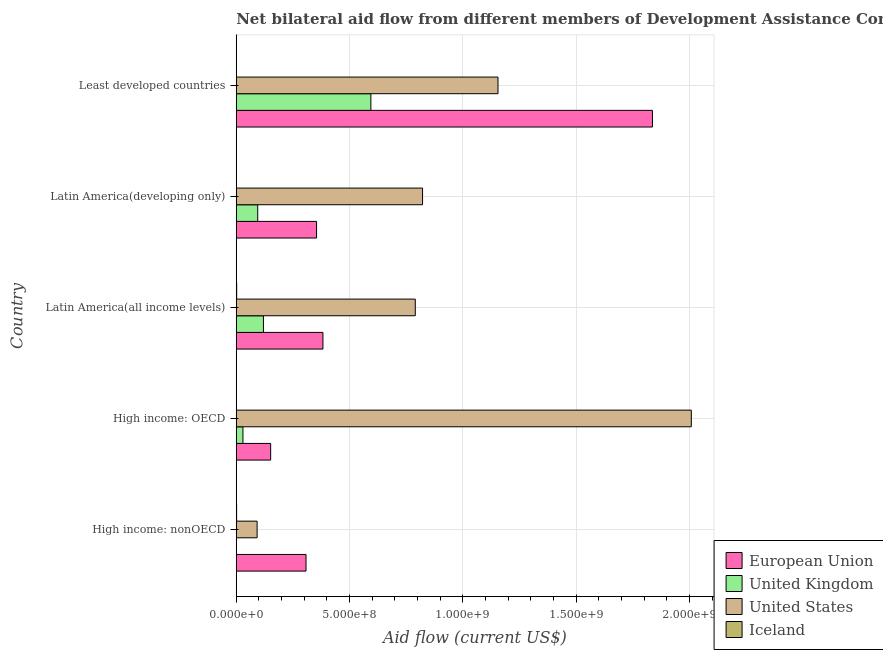How many groups of bars are there?
Your answer should be compact. 5. Are the number of bars per tick equal to the number of legend labels?
Offer a terse response. No. How many bars are there on the 3rd tick from the top?
Your answer should be compact. 4. What is the label of the 4th group of bars from the top?
Offer a terse response. High income: OECD. In how many cases, is the number of bars for a given country not equal to the number of legend labels?
Provide a short and direct response. 1. What is the amount of aid given by iceland in High income: nonOECD?
Make the answer very short. 1.55e+06. Across all countries, what is the maximum amount of aid given by us?
Your response must be concise. 2.01e+09. Across all countries, what is the minimum amount of aid given by eu?
Your answer should be compact. 1.52e+08. In which country was the amount of aid given by eu maximum?
Your answer should be very brief. Least developed countries. What is the total amount of aid given by us in the graph?
Your response must be concise. 4.87e+09. What is the difference between the amount of aid given by us in High income: nonOECD and that in Least developed countries?
Give a very brief answer. -1.06e+09. What is the difference between the amount of aid given by iceland in Least developed countries and the amount of aid given by eu in Latin America(all income levels)?
Your answer should be very brief. -3.82e+08. What is the average amount of aid given by eu per country?
Offer a very short reply. 6.07e+08. What is the difference between the amount of aid given by us and amount of aid given by eu in Latin America(developing only)?
Offer a very short reply. 4.68e+08. What is the difference between the highest and the second highest amount of aid given by us?
Make the answer very short. 8.53e+08. What is the difference between the highest and the lowest amount of aid given by eu?
Your answer should be compact. 1.68e+09. In how many countries, is the amount of aid given by eu greater than the average amount of aid given by eu taken over all countries?
Offer a very short reply. 1. Is it the case that in every country, the sum of the amount of aid given by eu and amount of aid given by uk is greater than the amount of aid given by us?
Your answer should be very brief. No. How many countries are there in the graph?
Your response must be concise. 5. What is the difference between two consecutive major ticks on the X-axis?
Keep it short and to the point. 5.00e+08. Where does the legend appear in the graph?
Give a very brief answer. Bottom right. How many legend labels are there?
Your answer should be compact. 4. How are the legend labels stacked?
Offer a terse response. Vertical. What is the title of the graph?
Make the answer very short. Net bilateral aid flow from different members of Development Assistance Committee in the year 1992. Does "Environmental sustainability" appear as one of the legend labels in the graph?
Your response must be concise. No. What is the label or title of the X-axis?
Ensure brevity in your answer.  Aid flow (current US$). What is the label or title of the Y-axis?
Provide a short and direct response. Country. What is the Aid flow (current US$) in European Union in High income: nonOECD?
Give a very brief answer. 3.08e+08. What is the Aid flow (current US$) of United Kingdom in High income: nonOECD?
Keep it short and to the point. 0. What is the Aid flow (current US$) in United States in High income: nonOECD?
Provide a short and direct response. 9.20e+07. What is the Aid flow (current US$) in Iceland in High income: nonOECD?
Ensure brevity in your answer.  1.55e+06. What is the Aid flow (current US$) in European Union in High income: OECD?
Ensure brevity in your answer.  1.52e+08. What is the Aid flow (current US$) in United Kingdom in High income: OECD?
Offer a very short reply. 2.95e+07. What is the Aid flow (current US$) of United States in High income: OECD?
Give a very brief answer. 2.01e+09. What is the Aid flow (current US$) in Iceland in High income: OECD?
Your response must be concise. 7.00e+05. What is the Aid flow (current US$) of European Union in Latin America(all income levels)?
Provide a succinct answer. 3.82e+08. What is the Aid flow (current US$) of United Kingdom in Latin America(all income levels)?
Keep it short and to the point. 1.20e+08. What is the Aid flow (current US$) of United States in Latin America(all income levels)?
Provide a succinct answer. 7.90e+08. What is the Aid flow (current US$) in Iceland in Latin America(all income levels)?
Make the answer very short. 1.85e+06. What is the Aid flow (current US$) in European Union in Latin America(developing only)?
Provide a short and direct response. 3.54e+08. What is the Aid flow (current US$) in United Kingdom in Latin America(developing only)?
Offer a terse response. 9.48e+07. What is the Aid flow (current US$) of United States in Latin America(developing only)?
Give a very brief answer. 8.22e+08. What is the Aid flow (current US$) of Iceland in Latin America(developing only)?
Your response must be concise. 1.00e+05. What is the Aid flow (current US$) of European Union in Least developed countries?
Offer a very short reply. 1.84e+09. What is the Aid flow (current US$) in United Kingdom in Least developed countries?
Offer a very short reply. 5.94e+08. What is the Aid flow (current US$) in United States in Least developed countries?
Your answer should be compact. 1.16e+09. What is the Aid flow (current US$) in Iceland in Least developed countries?
Your answer should be very brief. 7.50e+05. Across all countries, what is the maximum Aid flow (current US$) of European Union?
Make the answer very short. 1.84e+09. Across all countries, what is the maximum Aid flow (current US$) of United Kingdom?
Make the answer very short. 5.94e+08. Across all countries, what is the maximum Aid flow (current US$) of United States?
Provide a short and direct response. 2.01e+09. Across all countries, what is the maximum Aid flow (current US$) of Iceland?
Ensure brevity in your answer.  1.85e+06. Across all countries, what is the minimum Aid flow (current US$) of European Union?
Provide a short and direct response. 1.52e+08. Across all countries, what is the minimum Aid flow (current US$) of United Kingdom?
Offer a terse response. 0. Across all countries, what is the minimum Aid flow (current US$) in United States?
Give a very brief answer. 9.20e+07. Across all countries, what is the minimum Aid flow (current US$) in Iceland?
Provide a succinct answer. 1.00e+05. What is the total Aid flow (current US$) in European Union in the graph?
Provide a succinct answer. 3.03e+09. What is the total Aid flow (current US$) of United Kingdom in the graph?
Your answer should be compact. 8.38e+08. What is the total Aid flow (current US$) of United States in the graph?
Make the answer very short. 4.87e+09. What is the total Aid flow (current US$) of Iceland in the graph?
Make the answer very short. 4.95e+06. What is the difference between the Aid flow (current US$) of European Union in High income: nonOECD and that in High income: OECD?
Your response must be concise. 1.56e+08. What is the difference between the Aid flow (current US$) of United States in High income: nonOECD and that in High income: OECD?
Ensure brevity in your answer.  -1.92e+09. What is the difference between the Aid flow (current US$) of Iceland in High income: nonOECD and that in High income: OECD?
Keep it short and to the point. 8.50e+05. What is the difference between the Aid flow (current US$) of European Union in High income: nonOECD and that in Latin America(all income levels)?
Make the answer very short. -7.47e+07. What is the difference between the Aid flow (current US$) of United States in High income: nonOECD and that in Latin America(all income levels)?
Keep it short and to the point. -6.98e+08. What is the difference between the Aid flow (current US$) of Iceland in High income: nonOECD and that in Latin America(all income levels)?
Make the answer very short. -3.00e+05. What is the difference between the Aid flow (current US$) in European Union in High income: nonOECD and that in Latin America(developing only)?
Offer a terse response. -4.66e+07. What is the difference between the Aid flow (current US$) in United States in High income: nonOECD and that in Latin America(developing only)?
Provide a short and direct response. -7.30e+08. What is the difference between the Aid flow (current US$) in Iceland in High income: nonOECD and that in Latin America(developing only)?
Your answer should be very brief. 1.45e+06. What is the difference between the Aid flow (current US$) of European Union in High income: nonOECD and that in Least developed countries?
Give a very brief answer. -1.53e+09. What is the difference between the Aid flow (current US$) of United States in High income: nonOECD and that in Least developed countries?
Provide a short and direct response. -1.06e+09. What is the difference between the Aid flow (current US$) of European Union in High income: OECD and that in Latin America(all income levels)?
Provide a short and direct response. -2.31e+08. What is the difference between the Aid flow (current US$) in United Kingdom in High income: OECD and that in Latin America(all income levels)?
Your response must be concise. -9.05e+07. What is the difference between the Aid flow (current US$) of United States in High income: OECD and that in Latin America(all income levels)?
Give a very brief answer. 1.22e+09. What is the difference between the Aid flow (current US$) in Iceland in High income: OECD and that in Latin America(all income levels)?
Your response must be concise. -1.15e+06. What is the difference between the Aid flow (current US$) of European Union in High income: OECD and that in Latin America(developing only)?
Make the answer very short. -2.03e+08. What is the difference between the Aid flow (current US$) of United Kingdom in High income: OECD and that in Latin America(developing only)?
Your answer should be compact. -6.53e+07. What is the difference between the Aid flow (current US$) of United States in High income: OECD and that in Latin America(developing only)?
Your answer should be very brief. 1.19e+09. What is the difference between the Aid flow (current US$) in European Union in High income: OECD and that in Least developed countries?
Offer a terse response. -1.68e+09. What is the difference between the Aid flow (current US$) of United Kingdom in High income: OECD and that in Least developed countries?
Your answer should be very brief. -5.65e+08. What is the difference between the Aid flow (current US$) of United States in High income: OECD and that in Least developed countries?
Ensure brevity in your answer.  8.53e+08. What is the difference between the Aid flow (current US$) in European Union in Latin America(all income levels) and that in Latin America(developing only)?
Make the answer very short. 2.81e+07. What is the difference between the Aid flow (current US$) of United Kingdom in Latin America(all income levels) and that in Latin America(developing only)?
Ensure brevity in your answer.  2.52e+07. What is the difference between the Aid flow (current US$) of United States in Latin America(all income levels) and that in Latin America(developing only)?
Make the answer very short. -3.20e+07. What is the difference between the Aid flow (current US$) of Iceland in Latin America(all income levels) and that in Latin America(developing only)?
Provide a succinct answer. 1.75e+06. What is the difference between the Aid flow (current US$) in European Union in Latin America(all income levels) and that in Least developed countries?
Keep it short and to the point. -1.45e+09. What is the difference between the Aid flow (current US$) of United Kingdom in Latin America(all income levels) and that in Least developed countries?
Make the answer very short. -4.74e+08. What is the difference between the Aid flow (current US$) in United States in Latin America(all income levels) and that in Least developed countries?
Give a very brief answer. -3.65e+08. What is the difference between the Aid flow (current US$) in Iceland in Latin America(all income levels) and that in Least developed countries?
Ensure brevity in your answer.  1.10e+06. What is the difference between the Aid flow (current US$) in European Union in Latin America(developing only) and that in Least developed countries?
Make the answer very short. -1.48e+09. What is the difference between the Aid flow (current US$) in United Kingdom in Latin America(developing only) and that in Least developed countries?
Make the answer very short. -4.99e+08. What is the difference between the Aid flow (current US$) of United States in Latin America(developing only) and that in Least developed countries?
Give a very brief answer. -3.33e+08. What is the difference between the Aid flow (current US$) of Iceland in Latin America(developing only) and that in Least developed countries?
Your answer should be compact. -6.50e+05. What is the difference between the Aid flow (current US$) in European Union in High income: nonOECD and the Aid flow (current US$) in United Kingdom in High income: OECD?
Offer a terse response. 2.78e+08. What is the difference between the Aid flow (current US$) in European Union in High income: nonOECD and the Aid flow (current US$) in United States in High income: OECD?
Offer a terse response. -1.70e+09. What is the difference between the Aid flow (current US$) of European Union in High income: nonOECD and the Aid flow (current US$) of Iceland in High income: OECD?
Your answer should be very brief. 3.07e+08. What is the difference between the Aid flow (current US$) of United States in High income: nonOECD and the Aid flow (current US$) of Iceland in High income: OECD?
Make the answer very short. 9.13e+07. What is the difference between the Aid flow (current US$) in European Union in High income: nonOECD and the Aid flow (current US$) in United Kingdom in Latin America(all income levels)?
Provide a short and direct response. 1.88e+08. What is the difference between the Aid flow (current US$) of European Union in High income: nonOECD and the Aid flow (current US$) of United States in Latin America(all income levels)?
Keep it short and to the point. -4.82e+08. What is the difference between the Aid flow (current US$) in European Union in High income: nonOECD and the Aid flow (current US$) in Iceland in Latin America(all income levels)?
Make the answer very short. 3.06e+08. What is the difference between the Aid flow (current US$) in United States in High income: nonOECD and the Aid flow (current US$) in Iceland in Latin America(all income levels)?
Your answer should be very brief. 9.02e+07. What is the difference between the Aid flow (current US$) of European Union in High income: nonOECD and the Aid flow (current US$) of United Kingdom in Latin America(developing only)?
Your response must be concise. 2.13e+08. What is the difference between the Aid flow (current US$) in European Union in High income: nonOECD and the Aid flow (current US$) in United States in Latin America(developing only)?
Offer a terse response. -5.14e+08. What is the difference between the Aid flow (current US$) in European Union in High income: nonOECD and the Aid flow (current US$) in Iceland in Latin America(developing only)?
Your answer should be compact. 3.08e+08. What is the difference between the Aid flow (current US$) of United States in High income: nonOECD and the Aid flow (current US$) of Iceland in Latin America(developing only)?
Offer a very short reply. 9.19e+07. What is the difference between the Aid flow (current US$) of European Union in High income: nonOECD and the Aid flow (current US$) of United Kingdom in Least developed countries?
Provide a short and direct response. -2.86e+08. What is the difference between the Aid flow (current US$) of European Union in High income: nonOECD and the Aid flow (current US$) of United States in Least developed countries?
Your response must be concise. -8.47e+08. What is the difference between the Aid flow (current US$) in European Union in High income: nonOECD and the Aid flow (current US$) in Iceland in Least developed countries?
Ensure brevity in your answer.  3.07e+08. What is the difference between the Aid flow (current US$) of United States in High income: nonOECD and the Aid flow (current US$) of Iceland in Least developed countries?
Your answer should be compact. 9.12e+07. What is the difference between the Aid flow (current US$) in European Union in High income: OECD and the Aid flow (current US$) in United Kingdom in Latin America(all income levels)?
Your response must be concise. 3.18e+07. What is the difference between the Aid flow (current US$) in European Union in High income: OECD and the Aid flow (current US$) in United States in Latin America(all income levels)?
Offer a terse response. -6.38e+08. What is the difference between the Aid flow (current US$) of European Union in High income: OECD and the Aid flow (current US$) of Iceland in Latin America(all income levels)?
Provide a succinct answer. 1.50e+08. What is the difference between the Aid flow (current US$) of United Kingdom in High income: OECD and the Aid flow (current US$) of United States in Latin America(all income levels)?
Your response must be concise. -7.61e+08. What is the difference between the Aid flow (current US$) in United Kingdom in High income: OECD and the Aid flow (current US$) in Iceland in Latin America(all income levels)?
Your answer should be very brief. 2.76e+07. What is the difference between the Aid flow (current US$) in United States in High income: OECD and the Aid flow (current US$) in Iceland in Latin America(all income levels)?
Provide a short and direct response. 2.01e+09. What is the difference between the Aid flow (current US$) in European Union in High income: OECD and the Aid flow (current US$) in United Kingdom in Latin America(developing only)?
Your answer should be compact. 5.70e+07. What is the difference between the Aid flow (current US$) of European Union in High income: OECD and the Aid flow (current US$) of United States in Latin America(developing only)?
Provide a succinct answer. -6.70e+08. What is the difference between the Aid flow (current US$) of European Union in High income: OECD and the Aid flow (current US$) of Iceland in Latin America(developing only)?
Your answer should be very brief. 1.52e+08. What is the difference between the Aid flow (current US$) in United Kingdom in High income: OECD and the Aid flow (current US$) in United States in Latin America(developing only)?
Ensure brevity in your answer.  -7.93e+08. What is the difference between the Aid flow (current US$) in United Kingdom in High income: OECD and the Aid flow (current US$) in Iceland in Latin America(developing only)?
Offer a very short reply. 2.94e+07. What is the difference between the Aid flow (current US$) in United States in High income: OECD and the Aid flow (current US$) in Iceland in Latin America(developing only)?
Keep it short and to the point. 2.01e+09. What is the difference between the Aid flow (current US$) in European Union in High income: OECD and the Aid flow (current US$) in United Kingdom in Least developed countries?
Provide a succinct answer. -4.42e+08. What is the difference between the Aid flow (current US$) of European Union in High income: OECD and the Aid flow (current US$) of United States in Least developed countries?
Your answer should be compact. -1.00e+09. What is the difference between the Aid flow (current US$) in European Union in High income: OECD and the Aid flow (current US$) in Iceland in Least developed countries?
Ensure brevity in your answer.  1.51e+08. What is the difference between the Aid flow (current US$) in United Kingdom in High income: OECD and the Aid flow (current US$) in United States in Least developed countries?
Provide a succinct answer. -1.13e+09. What is the difference between the Aid flow (current US$) of United Kingdom in High income: OECD and the Aid flow (current US$) of Iceland in Least developed countries?
Offer a terse response. 2.87e+07. What is the difference between the Aid flow (current US$) of United States in High income: OECD and the Aid flow (current US$) of Iceland in Least developed countries?
Your response must be concise. 2.01e+09. What is the difference between the Aid flow (current US$) in European Union in Latin America(all income levels) and the Aid flow (current US$) in United Kingdom in Latin America(developing only)?
Make the answer very short. 2.88e+08. What is the difference between the Aid flow (current US$) of European Union in Latin America(all income levels) and the Aid flow (current US$) of United States in Latin America(developing only)?
Provide a succinct answer. -4.40e+08. What is the difference between the Aid flow (current US$) in European Union in Latin America(all income levels) and the Aid flow (current US$) in Iceland in Latin America(developing only)?
Your response must be concise. 3.82e+08. What is the difference between the Aid flow (current US$) of United Kingdom in Latin America(all income levels) and the Aid flow (current US$) of United States in Latin America(developing only)?
Your answer should be compact. -7.02e+08. What is the difference between the Aid flow (current US$) of United Kingdom in Latin America(all income levels) and the Aid flow (current US$) of Iceland in Latin America(developing only)?
Your answer should be very brief. 1.20e+08. What is the difference between the Aid flow (current US$) of United States in Latin America(all income levels) and the Aid flow (current US$) of Iceland in Latin America(developing only)?
Offer a terse response. 7.90e+08. What is the difference between the Aid flow (current US$) in European Union in Latin America(all income levels) and the Aid flow (current US$) in United Kingdom in Least developed countries?
Make the answer very short. -2.12e+08. What is the difference between the Aid flow (current US$) of European Union in Latin America(all income levels) and the Aid flow (current US$) of United States in Least developed countries?
Give a very brief answer. -7.73e+08. What is the difference between the Aid flow (current US$) in European Union in Latin America(all income levels) and the Aid flow (current US$) in Iceland in Least developed countries?
Provide a succinct answer. 3.82e+08. What is the difference between the Aid flow (current US$) in United Kingdom in Latin America(all income levels) and the Aid flow (current US$) in United States in Least developed countries?
Offer a very short reply. -1.04e+09. What is the difference between the Aid flow (current US$) in United Kingdom in Latin America(all income levels) and the Aid flow (current US$) in Iceland in Least developed countries?
Offer a very short reply. 1.19e+08. What is the difference between the Aid flow (current US$) of United States in Latin America(all income levels) and the Aid flow (current US$) of Iceland in Least developed countries?
Ensure brevity in your answer.  7.89e+08. What is the difference between the Aid flow (current US$) in European Union in Latin America(developing only) and the Aid flow (current US$) in United Kingdom in Least developed countries?
Ensure brevity in your answer.  -2.40e+08. What is the difference between the Aid flow (current US$) in European Union in Latin America(developing only) and the Aid flow (current US$) in United States in Least developed countries?
Offer a terse response. -8.01e+08. What is the difference between the Aid flow (current US$) of European Union in Latin America(developing only) and the Aid flow (current US$) of Iceland in Least developed countries?
Offer a very short reply. 3.54e+08. What is the difference between the Aid flow (current US$) in United Kingdom in Latin America(developing only) and the Aid flow (current US$) in United States in Least developed countries?
Make the answer very short. -1.06e+09. What is the difference between the Aid flow (current US$) of United Kingdom in Latin America(developing only) and the Aid flow (current US$) of Iceland in Least developed countries?
Provide a succinct answer. 9.40e+07. What is the difference between the Aid flow (current US$) in United States in Latin America(developing only) and the Aid flow (current US$) in Iceland in Least developed countries?
Your answer should be very brief. 8.21e+08. What is the average Aid flow (current US$) of European Union per country?
Ensure brevity in your answer.  6.07e+08. What is the average Aid flow (current US$) of United Kingdom per country?
Your response must be concise. 1.68e+08. What is the average Aid flow (current US$) in United States per country?
Give a very brief answer. 9.73e+08. What is the average Aid flow (current US$) of Iceland per country?
Provide a short and direct response. 9.90e+05. What is the difference between the Aid flow (current US$) in European Union and Aid flow (current US$) in United States in High income: nonOECD?
Offer a very short reply. 2.16e+08. What is the difference between the Aid flow (current US$) of European Union and Aid flow (current US$) of Iceland in High income: nonOECD?
Provide a short and direct response. 3.06e+08. What is the difference between the Aid flow (current US$) of United States and Aid flow (current US$) of Iceland in High income: nonOECD?
Your answer should be very brief. 9.04e+07. What is the difference between the Aid flow (current US$) of European Union and Aid flow (current US$) of United Kingdom in High income: OECD?
Offer a very short reply. 1.22e+08. What is the difference between the Aid flow (current US$) in European Union and Aid flow (current US$) in United States in High income: OECD?
Your response must be concise. -1.86e+09. What is the difference between the Aid flow (current US$) of European Union and Aid flow (current US$) of Iceland in High income: OECD?
Keep it short and to the point. 1.51e+08. What is the difference between the Aid flow (current US$) in United Kingdom and Aid flow (current US$) in United States in High income: OECD?
Your answer should be compact. -1.98e+09. What is the difference between the Aid flow (current US$) in United Kingdom and Aid flow (current US$) in Iceland in High income: OECD?
Provide a short and direct response. 2.88e+07. What is the difference between the Aid flow (current US$) in United States and Aid flow (current US$) in Iceland in High income: OECD?
Provide a succinct answer. 2.01e+09. What is the difference between the Aid flow (current US$) in European Union and Aid flow (current US$) in United Kingdom in Latin America(all income levels)?
Provide a short and direct response. 2.63e+08. What is the difference between the Aid flow (current US$) in European Union and Aid flow (current US$) in United States in Latin America(all income levels)?
Give a very brief answer. -4.08e+08. What is the difference between the Aid flow (current US$) in European Union and Aid flow (current US$) in Iceland in Latin America(all income levels)?
Provide a succinct answer. 3.81e+08. What is the difference between the Aid flow (current US$) of United Kingdom and Aid flow (current US$) of United States in Latin America(all income levels)?
Keep it short and to the point. -6.70e+08. What is the difference between the Aid flow (current US$) of United Kingdom and Aid flow (current US$) of Iceland in Latin America(all income levels)?
Your answer should be compact. 1.18e+08. What is the difference between the Aid flow (current US$) in United States and Aid flow (current US$) in Iceland in Latin America(all income levels)?
Keep it short and to the point. 7.88e+08. What is the difference between the Aid flow (current US$) of European Union and Aid flow (current US$) of United Kingdom in Latin America(developing only)?
Make the answer very short. 2.60e+08. What is the difference between the Aid flow (current US$) of European Union and Aid flow (current US$) of United States in Latin America(developing only)?
Ensure brevity in your answer.  -4.68e+08. What is the difference between the Aid flow (current US$) of European Union and Aid flow (current US$) of Iceland in Latin America(developing only)?
Offer a terse response. 3.54e+08. What is the difference between the Aid flow (current US$) in United Kingdom and Aid flow (current US$) in United States in Latin America(developing only)?
Your answer should be compact. -7.27e+08. What is the difference between the Aid flow (current US$) in United Kingdom and Aid flow (current US$) in Iceland in Latin America(developing only)?
Ensure brevity in your answer.  9.46e+07. What is the difference between the Aid flow (current US$) of United States and Aid flow (current US$) of Iceland in Latin America(developing only)?
Provide a short and direct response. 8.22e+08. What is the difference between the Aid flow (current US$) in European Union and Aid flow (current US$) in United Kingdom in Least developed countries?
Ensure brevity in your answer.  1.24e+09. What is the difference between the Aid flow (current US$) of European Union and Aid flow (current US$) of United States in Least developed countries?
Keep it short and to the point. 6.82e+08. What is the difference between the Aid flow (current US$) in European Union and Aid flow (current US$) in Iceland in Least developed countries?
Your answer should be compact. 1.84e+09. What is the difference between the Aid flow (current US$) in United Kingdom and Aid flow (current US$) in United States in Least developed countries?
Make the answer very short. -5.61e+08. What is the difference between the Aid flow (current US$) in United Kingdom and Aid flow (current US$) in Iceland in Least developed countries?
Offer a very short reply. 5.93e+08. What is the difference between the Aid flow (current US$) of United States and Aid flow (current US$) of Iceland in Least developed countries?
Offer a terse response. 1.15e+09. What is the ratio of the Aid flow (current US$) in European Union in High income: nonOECD to that in High income: OECD?
Offer a very short reply. 2.03. What is the ratio of the Aid flow (current US$) of United States in High income: nonOECD to that in High income: OECD?
Offer a very short reply. 0.05. What is the ratio of the Aid flow (current US$) of Iceland in High income: nonOECD to that in High income: OECD?
Offer a terse response. 2.21. What is the ratio of the Aid flow (current US$) in European Union in High income: nonOECD to that in Latin America(all income levels)?
Make the answer very short. 0.8. What is the ratio of the Aid flow (current US$) of United States in High income: nonOECD to that in Latin America(all income levels)?
Your response must be concise. 0.12. What is the ratio of the Aid flow (current US$) in Iceland in High income: nonOECD to that in Latin America(all income levels)?
Offer a very short reply. 0.84. What is the ratio of the Aid flow (current US$) in European Union in High income: nonOECD to that in Latin America(developing only)?
Offer a terse response. 0.87. What is the ratio of the Aid flow (current US$) in United States in High income: nonOECD to that in Latin America(developing only)?
Keep it short and to the point. 0.11. What is the ratio of the Aid flow (current US$) in Iceland in High income: nonOECD to that in Latin America(developing only)?
Make the answer very short. 15.5. What is the ratio of the Aid flow (current US$) in European Union in High income: nonOECD to that in Least developed countries?
Make the answer very short. 0.17. What is the ratio of the Aid flow (current US$) of United States in High income: nonOECD to that in Least developed countries?
Ensure brevity in your answer.  0.08. What is the ratio of the Aid flow (current US$) of Iceland in High income: nonOECD to that in Least developed countries?
Make the answer very short. 2.07. What is the ratio of the Aid flow (current US$) in European Union in High income: OECD to that in Latin America(all income levels)?
Keep it short and to the point. 0.4. What is the ratio of the Aid flow (current US$) of United Kingdom in High income: OECD to that in Latin America(all income levels)?
Your response must be concise. 0.25. What is the ratio of the Aid flow (current US$) in United States in High income: OECD to that in Latin America(all income levels)?
Offer a terse response. 2.54. What is the ratio of the Aid flow (current US$) in Iceland in High income: OECD to that in Latin America(all income levels)?
Make the answer very short. 0.38. What is the ratio of the Aid flow (current US$) of European Union in High income: OECD to that in Latin America(developing only)?
Your answer should be very brief. 0.43. What is the ratio of the Aid flow (current US$) of United Kingdom in High income: OECD to that in Latin America(developing only)?
Your answer should be very brief. 0.31. What is the ratio of the Aid flow (current US$) in United States in High income: OECD to that in Latin America(developing only)?
Keep it short and to the point. 2.44. What is the ratio of the Aid flow (current US$) in European Union in High income: OECD to that in Least developed countries?
Ensure brevity in your answer.  0.08. What is the ratio of the Aid flow (current US$) of United Kingdom in High income: OECD to that in Least developed countries?
Provide a succinct answer. 0.05. What is the ratio of the Aid flow (current US$) of United States in High income: OECD to that in Least developed countries?
Your answer should be very brief. 1.74. What is the ratio of the Aid flow (current US$) of Iceland in High income: OECD to that in Least developed countries?
Offer a very short reply. 0.93. What is the ratio of the Aid flow (current US$) in European Union in Latin America(all income levels) to that in Latin America(developing only)?
Ensure brevity in your answer.  1.08. What is the ratio of the Aid flow (current US$) in United Kingdom in Latin America(all income levels) to that in Latin America(developing only)?
Offer a terse response. 1.27. What is the ratio of the Aid flow (current US$) in United States in Latin America(all income levels) to that in Latin America(developing only)?
Make the answer very short. 0.96. What is the ratio of the Aid flow (current US$) in Iceland in Latin America(all income levels) to that in Latin America(developing only)?
Provide a short and direct response. 18.5. What is the ratio of the Aid flow (current US$) of European Union in Latin America(all income levels) to that in Least developed countries?
Provide a succinct answer. 0.21. What is the ratio of the Aid flow (current US$) of United Kingdom in Latin America(all income levels) to that in Least developed countries?
Offer a very short reply. 0.2. What is the ratio of the Aid flow (current US$) of United States in Latin America(all income levels) to that in Least developed countries?
Your response must be concise. 0.68. What is the ratio of the Aid flow (current US$) in Iceland in Latin America(all income levels) to that in Least developed countries?
Your response must be concise. 2.47. What is the ratio of the Aid flow (current US$) of European Union in Latin America(developing only) to that in Least developed countries?
Make the answer very short. 0.19. What is the ratio of the Aid flow (current US$) of United Kingdom in Latin America(developing only) to that in Least developed countries?
Your answer should be compact. 0.16. What is the ratio of the Aid flow (current US$) of United States in Latin America(developing only) to that in Least developed countries?
Keep it short and to the point. 0.71. What is the ratio of the Aid flow (current US$) of Iceland in Latin America(developing only) to that in Least developed countries?
Your answer should be very brief. 0.13. What is the difference between the highest and the second highest Aid flow (current US$) of European Union?
Give a very brief answer. 1.45e+09. What is the difference between the highest and the second highest Aid flow (current US$) of United Kingdom?
Offer a terse response. 4.74e+08. What is the difference between the highest and the second highest Aid flow (current US$) in United States?
Ensure brevity in your answer.  8.53e+08. What is the difference between the highest and the second highest Aid flow (current US$) in Iceland?
Ensure brevity in your answer.  3.00e+05. What is the difference between the highest and the lowest Aid flow (current US$) of European Union?
Give a very brief answer. 1.68e+09. What is the difference between the highest and the lowest Aid flow (current US$) in United Kingdom?
Your answer should be very brief. 5.94e+08. What is the difference between the highest and the lowest Aid flow (current US$) of United States?
Your answer should be compact. 1.92e+09. What is the difference between the highest and the lowest Aid flow (current US$) in Iceland?
Make the answer very short. 1.75e+06. 